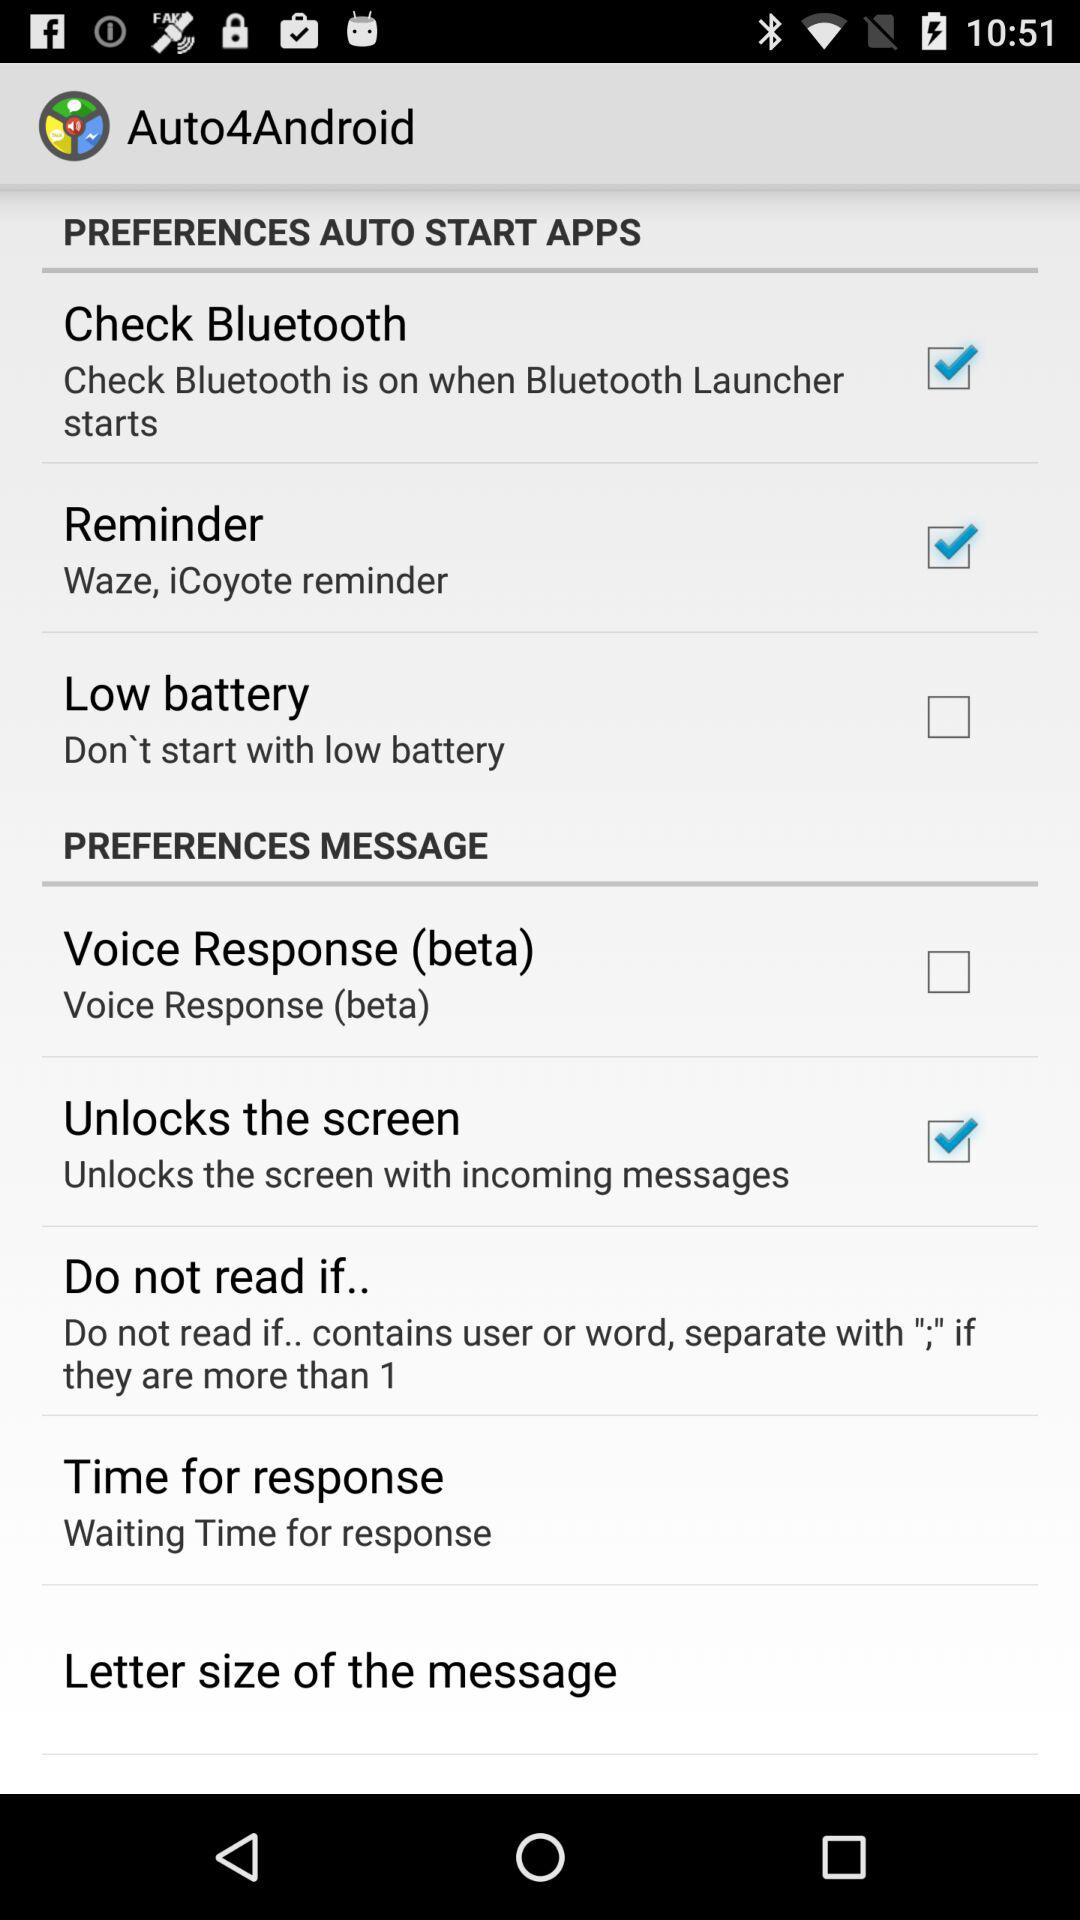What is the name of the application? The name of the application is "Auto4Android". 